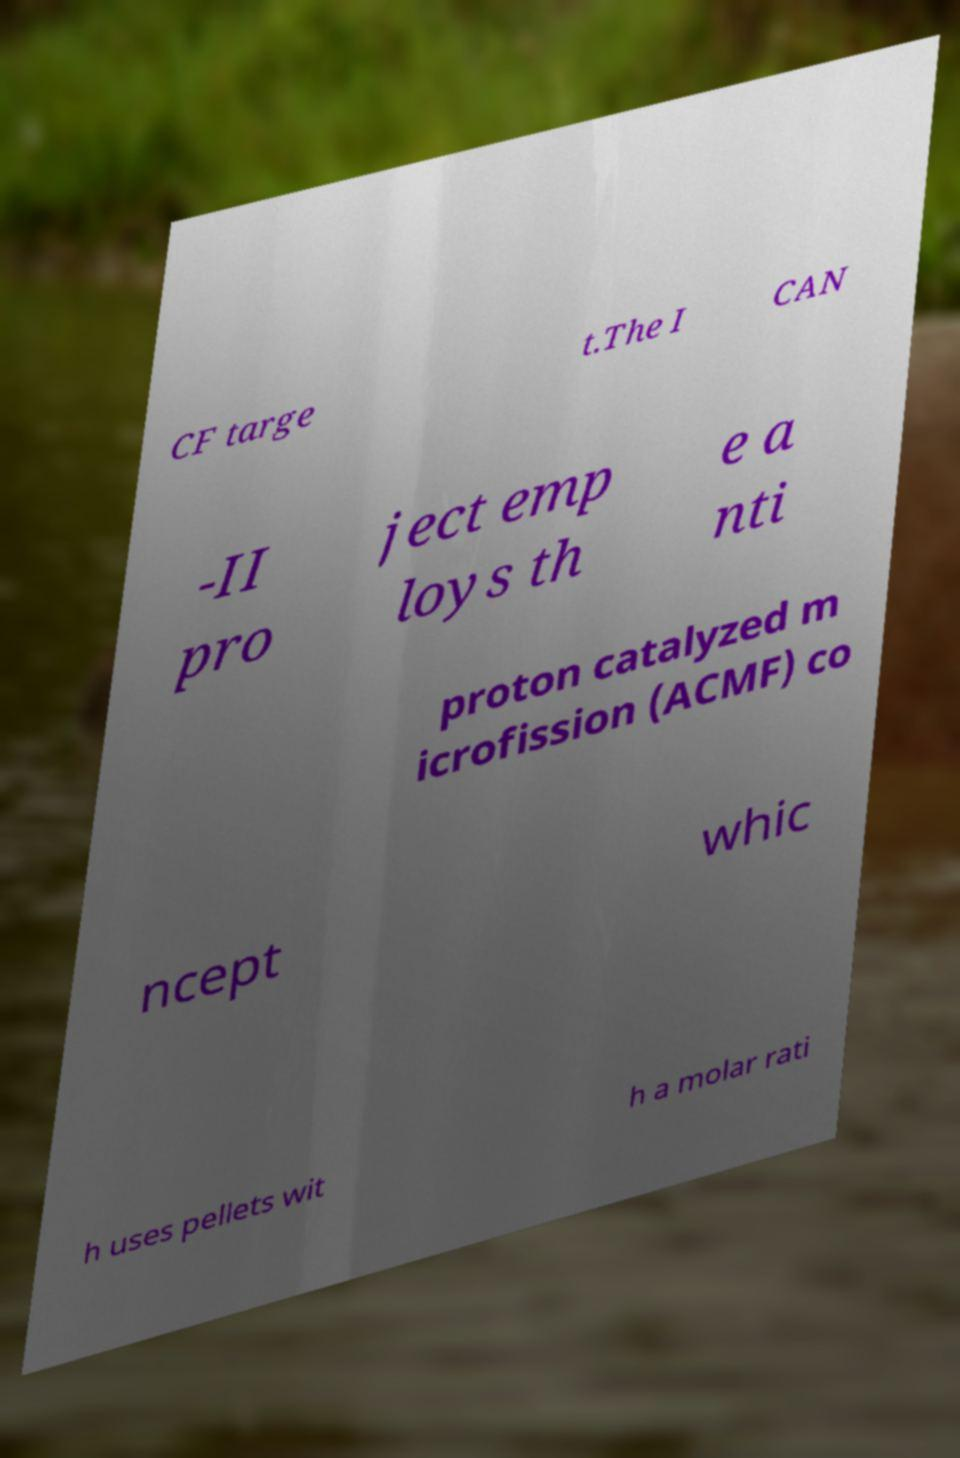Could you assist in decoding the text presented in this image and type it out clearly? CF targe t.The I CAN -II pro ject emp loys th e a nti proton catalyzed m icrofission (ACMF) co ncept whic h uses pellets wit h a molar rati 